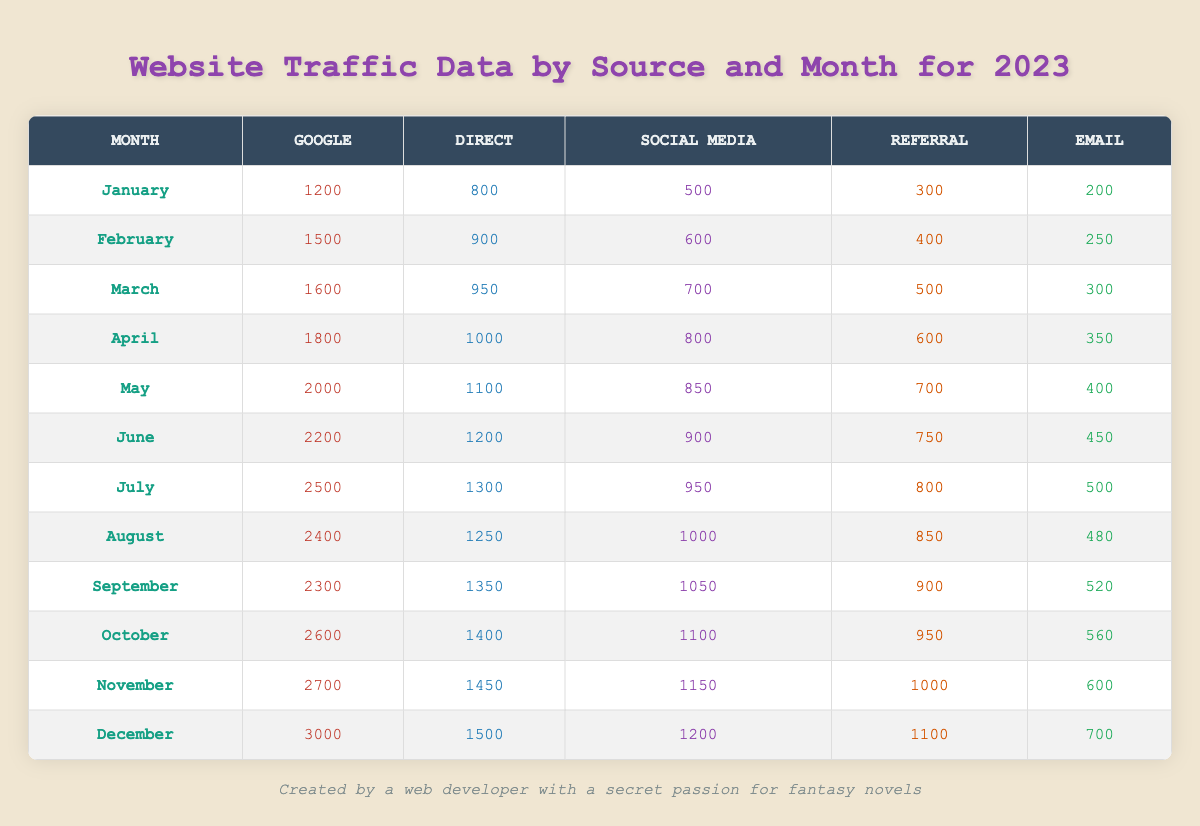What was the total traffic from Google in December? The table shows that the traffic from Google in December is 3000.
Answer: 3000 What is the highest traffic recorded from Direct sources in any month? The highest traffic from Direct sources is 1500 in December.
Answer: 1500 How many visits came from Social Media in March? According to the table, the traffic from Social Media in March is 700.
Answer: 700 What was the total traffic from all sources in June? The total traffic for June is calculated as follows: Google (2200) + Direct (1200) + Social Media (900) + Referral (750) + Email (450) = 4550.
Answer: 4550 Did the traffic from Email sources increase every month? By checking the Email column, we see the values: 200, 250, 300, 350, 400, 450, 500, 480, 520, 560, 600, 700. The value in August decreased (480), so the statement is false.
Answer: No What was the average traffic from Referral sources over the entire year? First, sum the Referral traffic: 300 + 400 + 500 + 600 + 700 + 750 + 800 + 850 + 900 + 950 + 1000 + 1100 = 8550. There are 12 months, so the average is 8550 / 12 = 712.5.
Answer: 712.5 Which month had the least traffic from Social Media? The table shows that January had the least traffic from Social Media with a value of 500.
Answer: January What is the difference in traffic from Google between May and January? Google traffic in May is 2000, while in January it is 1200. The difference is 2000 - 1200 = 800.
Answer: 800 In which month did Direct traffic exceed 1300? The table indicates that Direct traffic exceeded 1300 starting from July when it reached 1300.
Answer: July What was the total traffic from all sources for the entire year? Summing all monthly totals gives: (1200 + 800 + 500 + 300 + 200) + (1500 + 900 + 600 + 400 + 250) + (1600 + 950 + 700 + 500 + 300) + (1800 + 1000 + 800 + 600 + 350) + (2000 + 1100 + 850 + 700 + 400) + (2200 + 1200 + 900 + 750 + 450) + (2500 + 1300 + 950 + 800 + 500) + (2400 + 1250 + 1000 + 850 + 480) + (2300 + 1350 + 1050 + 900 + 520) + (2600 + 1400 + 1100 + 950 + 560) + (2700 + 1450 + 1150 + 1000 + 600) + (3000 + 1500 + 1200 + 1100 + 700). The total is 28550.
Answer: 28550 